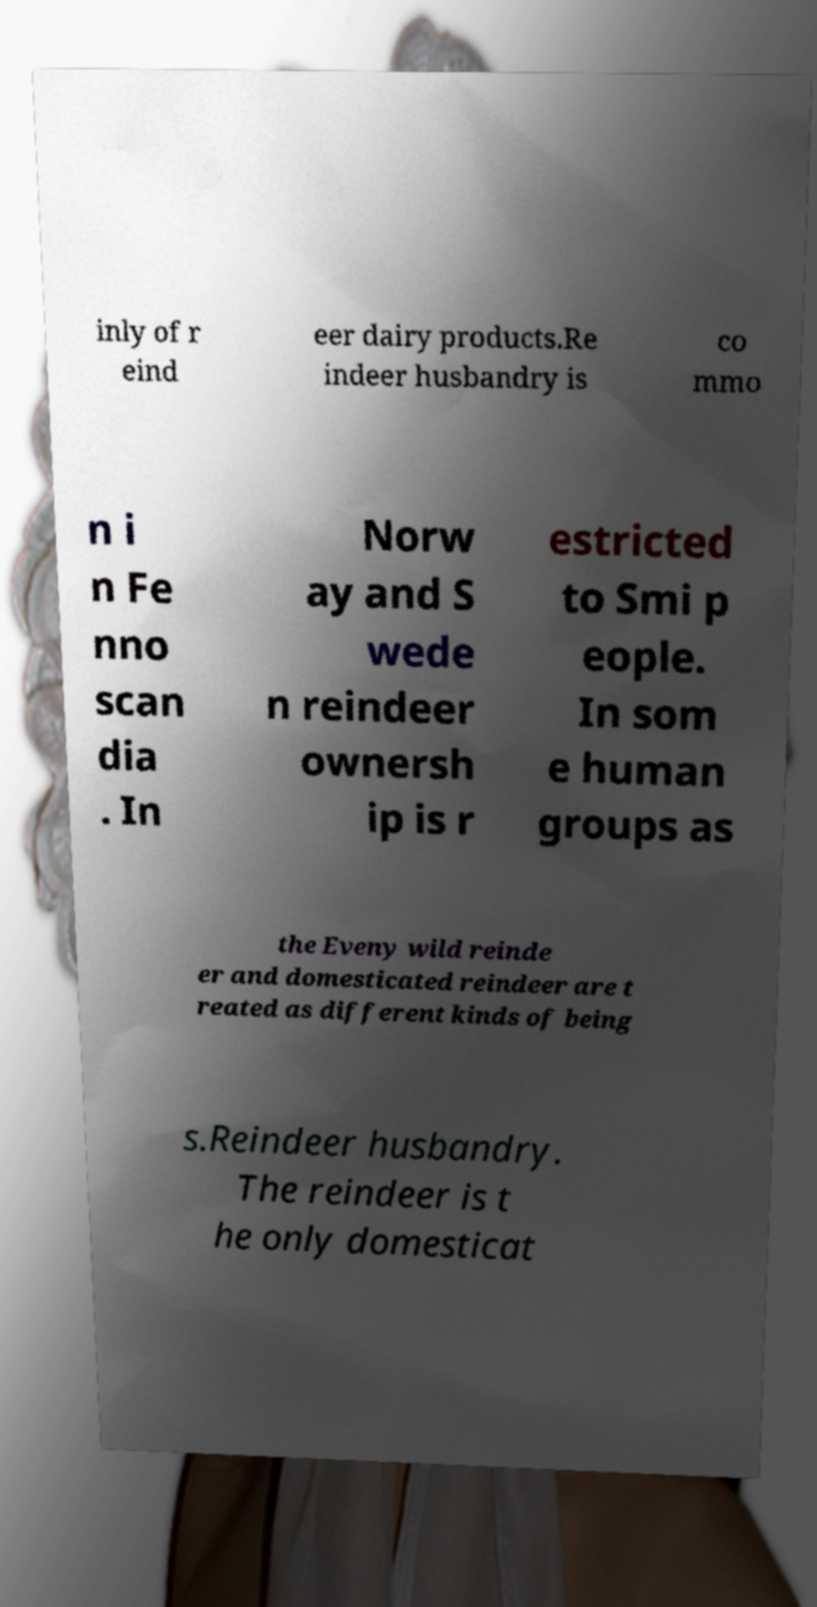Could you extract and type out the text from this image? inly of r eind eer dairy products.Re indeer husbandry is co mmo n i n Fe nno scan dia . In Norw ay and S wede n reindeer ownersh ip is r estricted to Smi p eople. In som e human groups as the Eveny wild reinde er and domesticated reindeer are t reated as different kinds of being s.Reindeer husbandry. The reindeer is t he only domesticat 